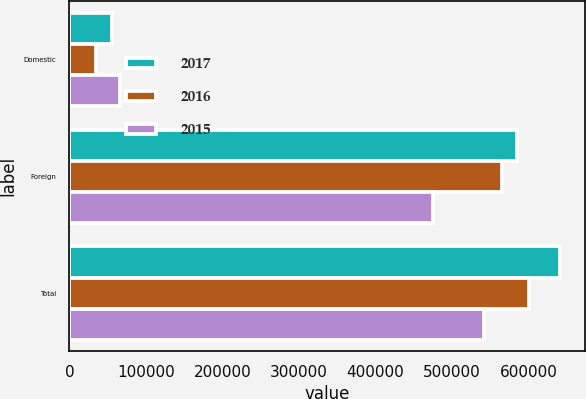Convert chart to OTSL. <chart><loc_0><loc_0><loc_500><loc_500><stacked_bar_chart><ecel><fcel>Domestic<fcel>Foreign<fcel>Total<nl><fcel>2017<fcel>55751<fcel>585346<fcel>641097<nl><fcel>2016<fcel>35154<fcel>564960<fcel>600114<nl><fcel>2015<fcel>66716<fcel>475203<fcel>541919<nl></chart> 